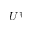<formula> <loc_0><loc_0><loc_500><loc_500>U ^ { \dagger }</formula> 